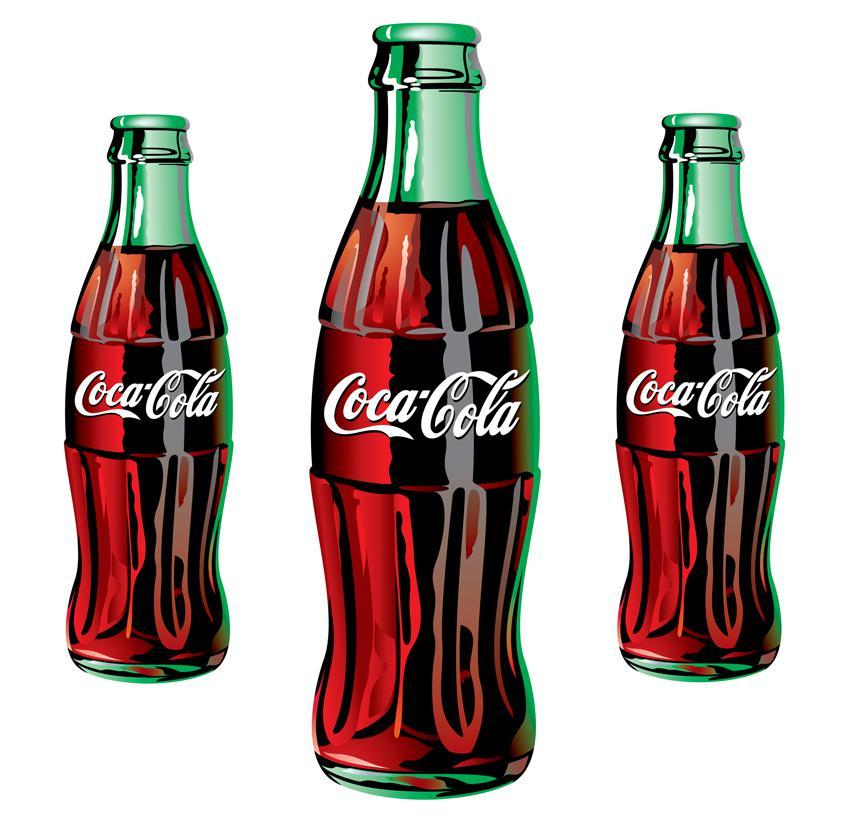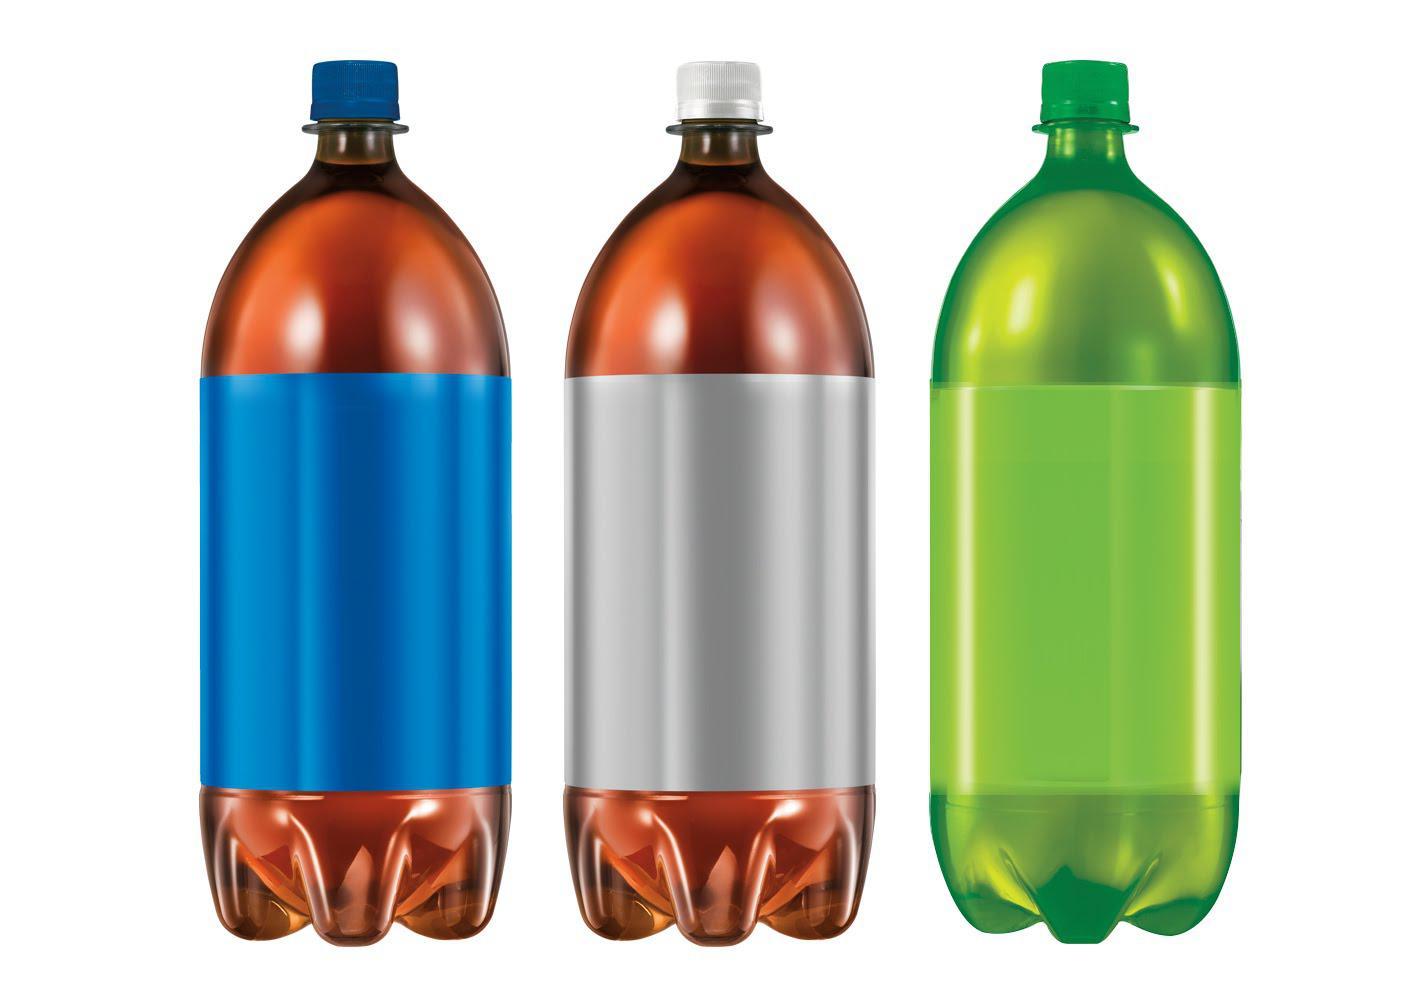The first image is the image on the left, the second image is the image on the right. Considering the images on both sides, is "One of the images shows at least one bottle of Coca-Cola." valid? Answer yes or no. Yes. The first image is the image on the left, the second image is the image on the right. Examine the images to the left and right. Is the description "There is one bottle in one of the images, and three in the other." accurate? Answer yes or no. No. 